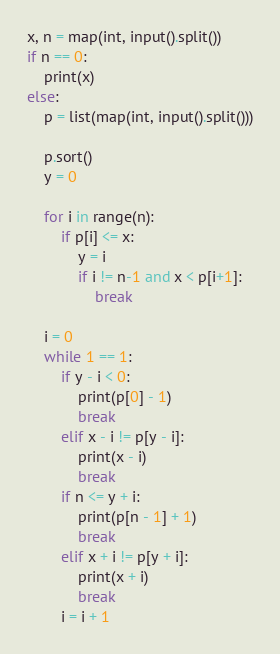<code> <loc_0><loc_0><loc_500><loc_500><_Python_>x, n = map(int, input().split())
if n == 0:
    print(x)
else:
    p = list(map(int, input().split()))

    p.sort()
    y = 0

    for i in range(n):
        if p[i] <= x:
            y = i
            if i != n-1 and x < p[i+1]:
                break 

    i = 0
    while 1 == 1:
        if y - i < 0:
            print(p[0] - 1)
            break
        elif x - i != p[y - i]:
            print(x - i)
            break
        if n <= y + i:
            print(p[n - 1] + 1)
            break
        elif x + i != p[y + i]:
            print(x + i)
            break
        i = i + 1</code> 